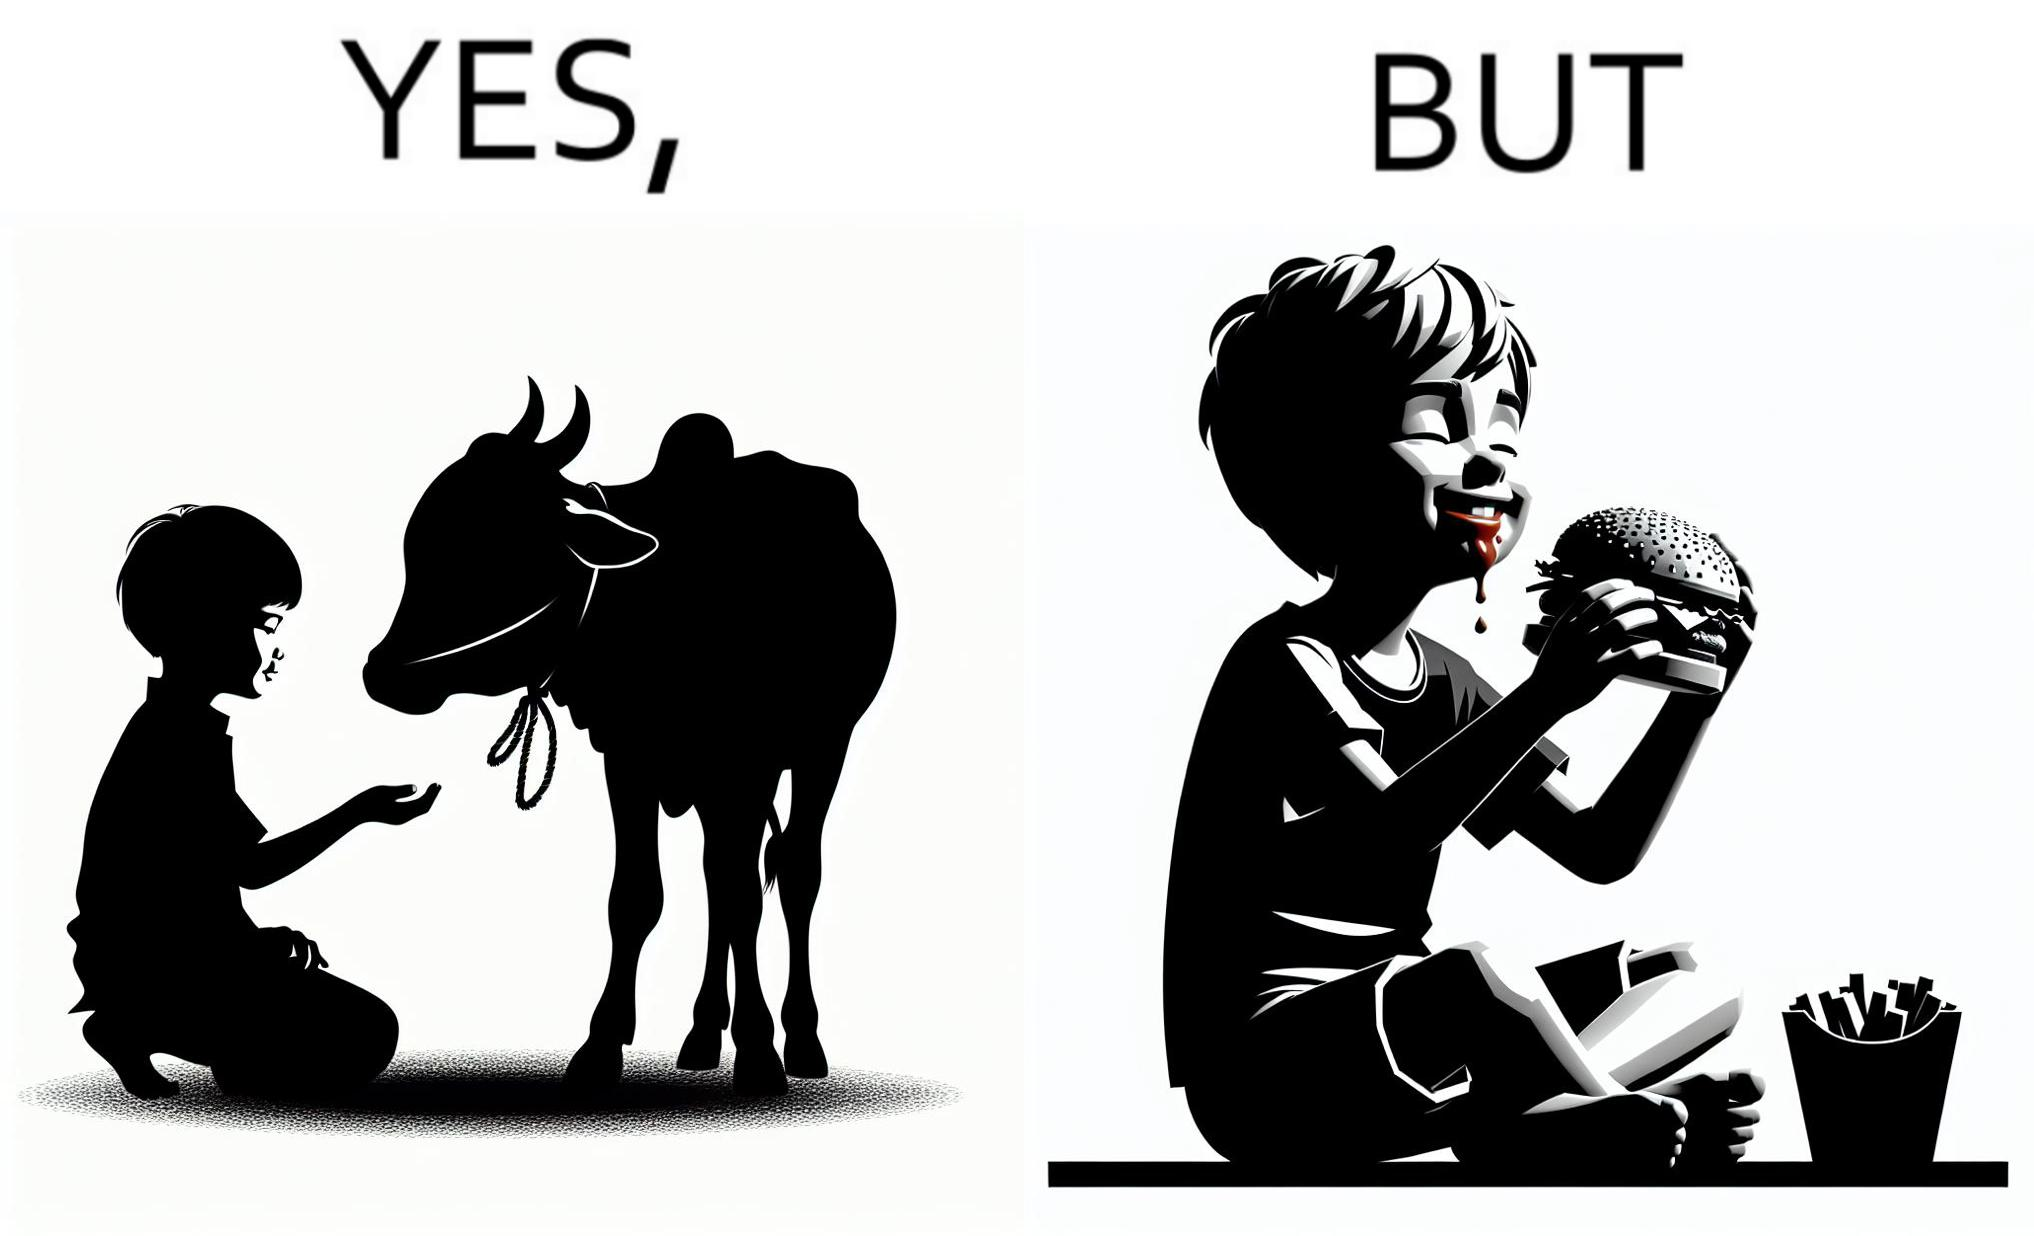Describe the satirical element in this image. The irony is that the boy is petting the cow to show that he cares about the animal, but then he also eats hamburgers made from the same cows 